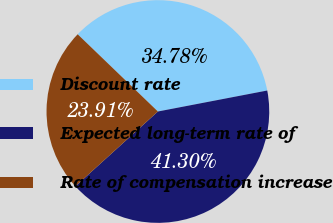Convert chart to OTSL. <chart><loc_0><loc_0><loc_500><loc_500><pie_chart><fcel>Discount rate<fcel>Expected long-term rate of<fcel>Rate of compensation increase<nl><fcel>34.78%<fcel>41.3%<fcel>23.91%<nl></chart> 